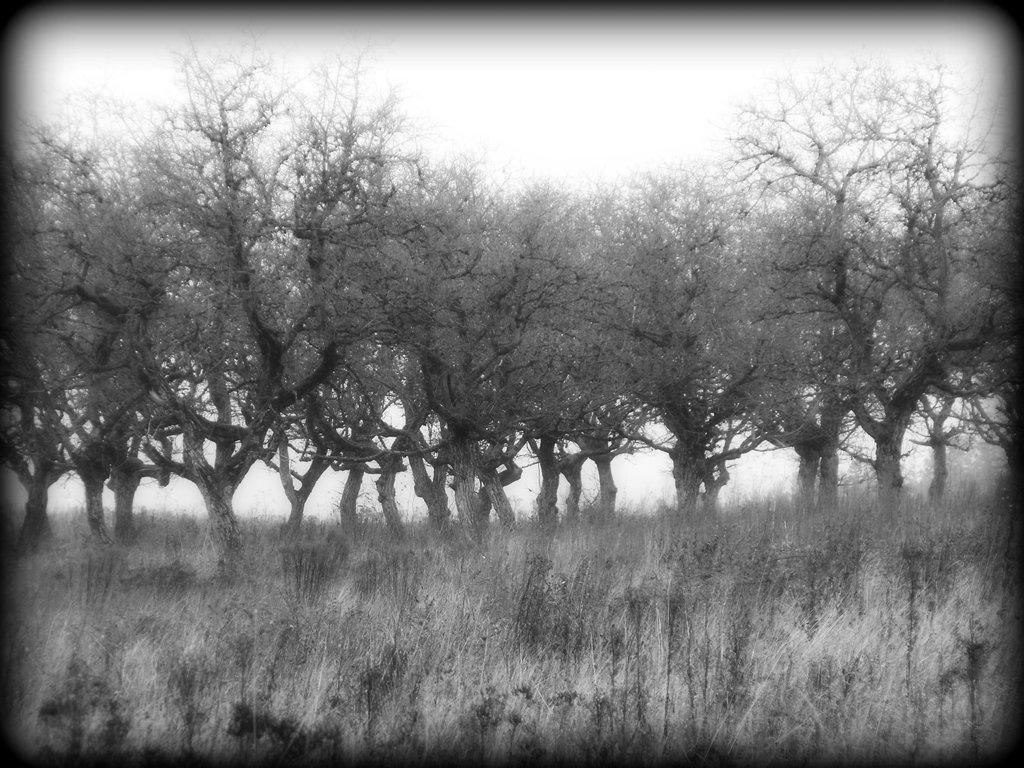How would you summarize this image in a sentence or two? This is a black and white image. In this image we can see trees, lawn straw and sky. 